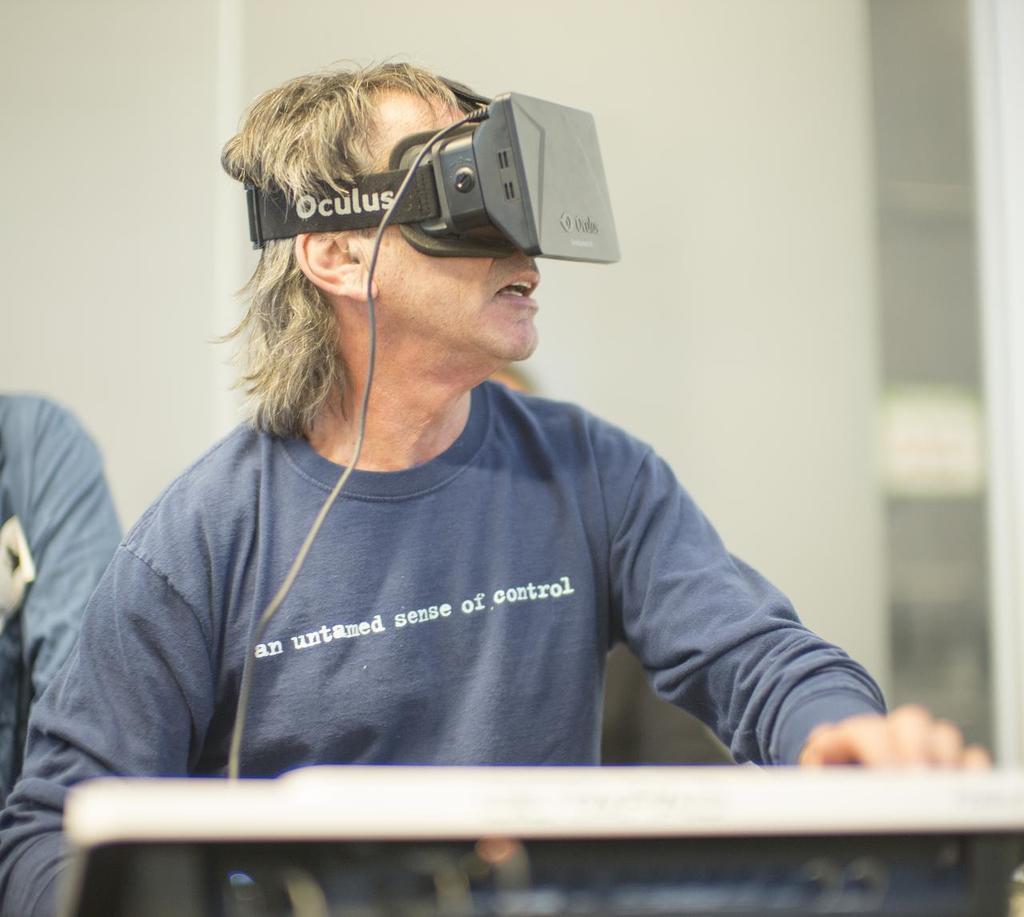Please provide a concise description of this image. In the middle of the image there is a man with blue t-shirt is standing and he kept VR box to his eyes. And in the background there is a white color. Beside him to the left side there is a person. 